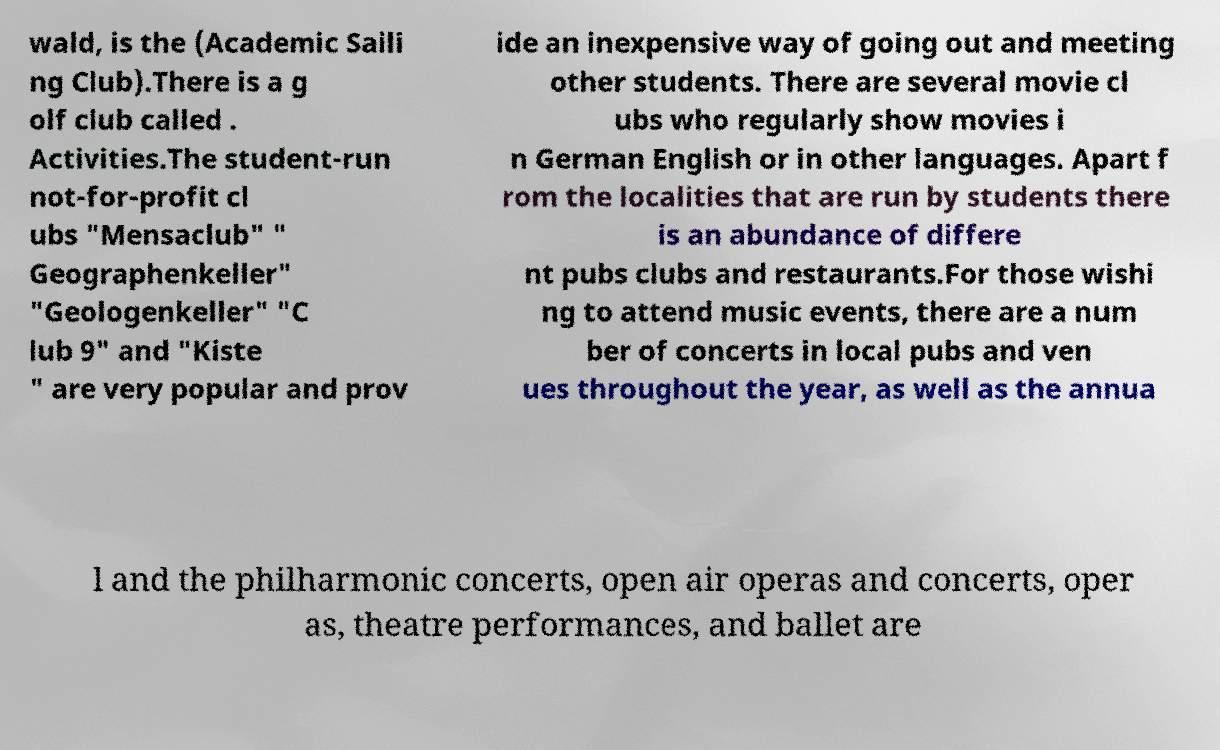Could you extract and type out the text from this image? wald, is the (Academic Saili ng Club).There is a g olf club called . Activities.The student-run not-for-profit cl ubs "Mensaclub" " Geographenkeller" "Geologenkeller" "C lub 9" and "Kiste " are very popular and prov ide an inexpensive way of going out and meeting other students. There are several movie cl ubs who regularly show movies i n German English or in other languages. Apart f rom the localities that are run by students there is an abundance of differe nt pubs clubs and restaurants.For those wishi ng to attend music events, there are a num ber of concerts in local pubs and ven ues throughout the year, as well as the annua l and the philharmonic concerts, open air operas and concerts, oper as, theatre performances, and ballet are 